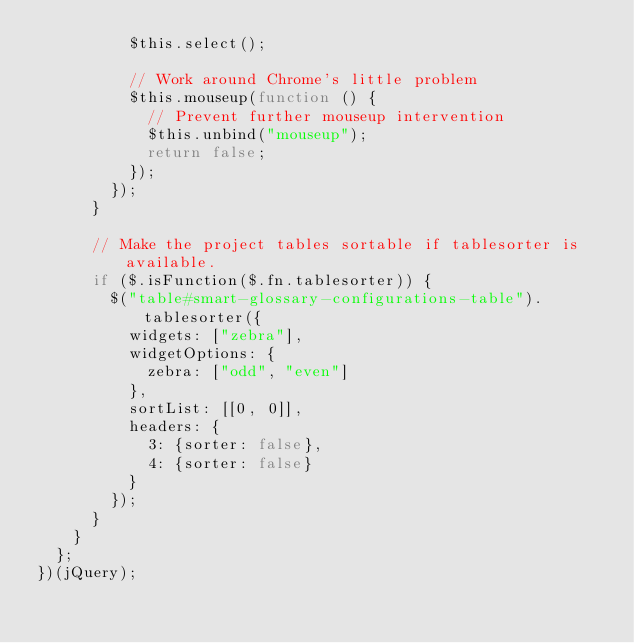<code> <loc_0><loc_0><loc_500><loc_500><_JavaScript_>          $this.select();

          // Work around Chrome's little problem
          $this.mouseup(function () {
            // Prevent further mouseup intervention
            $this.unbind("mouseup");
            return false;
          });
        });
      }

      // Make the project tables sortable if tablesorter is available.
      if ($.isFunction($.fn.tablesorter)) {
        $("table#smart-glossary-configurations-table").tablesorter({
          widgets: ["zebra"],
          widgetOptions: {
            zebra: ["odd", "even"]
          },
          sortList: [[0, 0]],
          headers: {
            3: {sorter: false},
            4: {sorter: false}
          }
        });
      }
    }
  };
})(jQuery);
</code> 